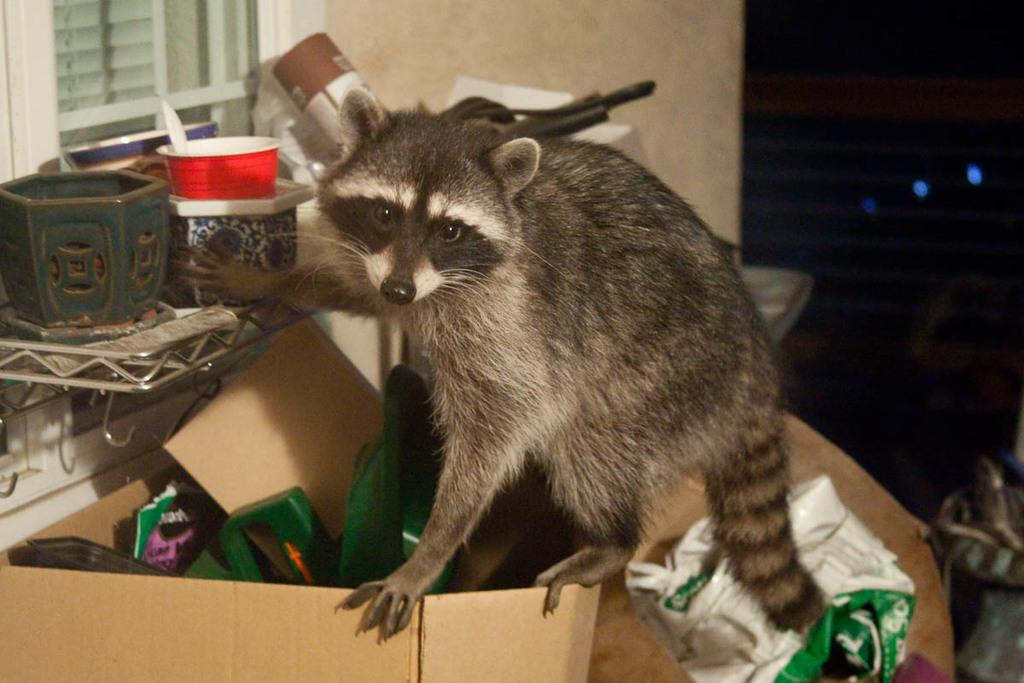What type of animal is present in the image? There is an animal in the image, but we cannot determine its specific type without more information. What is the animal interacting with in the image? The animal is interacting with a cardboard box in the image. What other objects can be seen in the image? There are some other objects in the image, but we cannot describe them without more information. What is the effect of the eggnog on the animal in the image? There is no eggnog present in the image, so we cannot determine its effect on the animal. 